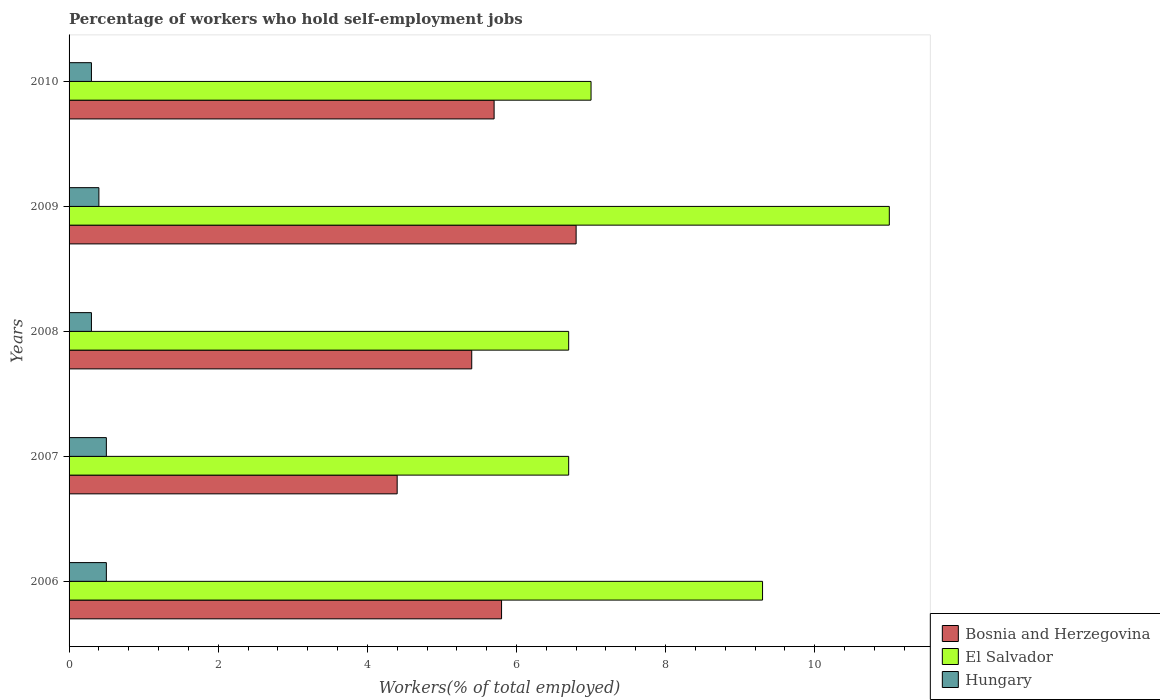How many different coloured bars are there?
Make the answer very short. 3. How many groups of bars are there?
Give a very brief answer. 5. Are the number of bars per tick equal to the number of legend labels?
Offer a very short reply. Yes. How many bars are there on the 3rd tick from the top?
Ensure brevity in your answer.  3. How many bars are there on the 4th tick from the bottom?
Your response must be concise. 3. What is the label of the 2nd group of bars from the top?
Ensure brevity in your answer.  2009. In how many cases, is the number of bars for a given year not equal to the number of legend labels?
Make the answer very short. 0. What is the percentage of self-employed workers in El Salvador in 2007?
Offer a very short reply. 6.7. Across all years, what is the maximum percentage of self-employed workers in Bosnia and Herzegovina?
Your answer should be compact. 6.8. Across all years, what is the minimum percentage of self-employed workers in Hungary?
Your response must be concise. 0.3. In which year was the percentage of self-employed workers in Bosnia and Herzegovina minimum?
Offer a very short reply. 2007. What is the total percentage of self-employed workers in El Salvador in the graph?
Provide a succinct answer. 40.7. What is the difference between the percentage of self-employed workers in Hungary in 2006 and that in 2007?
Your answer should be compact. 0. What is the difference between the percentage of self-employed workers in Bosnia and Herzegovina in 2010 and the percentage of self-employed workers in Hungary in 2006?
Your answer should be compact. 5.2. What is the average percentage of self-employed workers in El Salvador per year?
Give a very brief answer. 8.14. In the year 2006, what is the difference between the percentage of self-employed workers in Hungary and percentage of self-employed workers in Bosnia and Herzegovina?
Keep it short and to the point. -5.3. What is the ratio of the percentage of self-employed workers in El Salvador in 2008 to that in 2009?
Your answer should be compact. 0.61. Is the percentage of self-employed workers in El Salvador in 2009 less than that in 2010?
Give a very brief answer. No. Is the difference between the percentage of self-employed workers in Hungary in 2007 and 2008 greater than the difference between the percentage of self-employed workers in Bosnia and Herzegovina in 2007 and 2008?
Offer a terse response. Yes. What is the difference between the highest and the lowest percentage of self-employed workers in Hungary?
Give a very brief answer. 0.2. In how many years, is the percentage of self-employed workers in Hungary greater than the average percentage of self-employed workers in Hungary taken over all years?
Keep it short and to the point. 2. Is the sum of the percentage of self-employed workers in Bosnia and Herzegovina in 2007 and 2009 greater than the maximum percentage of self-employed workers in El Salvador across all years?
Give a very brief answer. Yes. What does the 1st bar from the top in 2006 represents?
Provide a short and direct response. Hungary. What does the 1st bar from the bottom in 2008 represents?
Your answer should be compact. Bosnia and Herzegovina. How many bars are there?
Give a very brief answer. 15. Are all the bars in the graph horizontal?
Provide a succinct answer. Yes. What is the difference between two consecutive major ticks on the X-axis?
Offer a terse response. 2. Are the values on the major ticks of X-axis written in scientific E-notation?
Make the answer very short. No. Does the graph contain any zero values?
Provide a short and direct response. No. What is the title of the graph?
Offer a very short reply. Percentage of workers who hold self-employment jobs. What is the label or title of the X-axis?
Provide a succinct answer. Workers(% of total employed). What is the Workers(% of total employed) of Bosnia and Herzegovina in 2006?
Give a very brief answer. 5.8. What is the Workers(% of total employed) of El Salvador in 2006?
Your answer should be very brief. 9.3. What is the Workers(% of total employed) in Hungary in 2006?
Your response must be concise. 0.5. What is the Workers(% of total employed) in Bosnia and Herzegovina in 2007?
Provide a short and direct response. 4.4. What is the Workers(% of total employed) of El Salvador in 2007?
Give a very brief answer. 6.7. What is the Workers(% of total employed) of Hungary in 2007?
Give a very brief answer. 0.5. What is the Workers(% of total employed) in Bosnia and Herzegovina in 2008?
Your answer should be compact. 5.4. What is the Workers(% of total employed) in El Salvador in 2008?
Give a very brief answer. 6.7. What is the Workers(% of total employed) in Hungary in 2008?
Give a very brief answer. 0.3. What is the Workers(% of total employed) of Bosnia and Herzegovina in 2009?
Your response must be concise. 6.8. What is the Workers(% of total employed) of Hungary in 2009?
Make the answer very short. 0.4. What is the Workers(% of total employed) of Bosnia and Herzegovina in 2010?
Offer a very short reply. 5.7. What is the Workers(% of total employed) in Hungary in 2010?
Give a very brief answer. 0.3. Across all years, what is the maximum Workers(% of total employed) in Bosnia and Herzegovina?
Offer a terse response. 6.8. Across all years, what is the minimum Workers(% of total employed) in Bosnia and Herzegovina?
Your answer should be very brief. 4.4. Across all years, what is the minimum Workers(% of total employed) of El Salvador?
Offer a terse response. 6.7. Across all years, what is the minimum Workers(% of total employed) in Hungary?
Keep it short and to the point. 0.3. What is the total Workers(% of total employed) of Bosnia and Herzegovina in the graph?
Offer a terse response. 28.1. What is the total Workers(% of total employed) of El Salvador in the graph?
Keep it short and to the point. 40.7. What is the difference between the Workers(% of total employed) in Bosnia and Herzegovina in 2006 and that in 2007?
Your response must be concise. 1.4. What is the difference between the Workers(% of total employed) in Hungary in 2006 and that in 2008?
Provide a succinct answer. 0.2. What is the difference between the Workers(% of total employed) of Bosnia and Herzegovina in 2006 and that in 2010?
Your response must be concise. 0.1. What is the difference between the Workers(% of total employed) of El Salvador in 2006 and that in 2010?
Your answer should be very brief. 2.3. What is the difference between the Workers(% of total employed) of Hungary in 2007 and that in 2008?
Offer a very short reply. 0.2. What is the difference between the Workers(% of total employed) of El Salvador in 2007 and that in 2009?
Keep it short and to the point. -4.3. What is the difference between the Workers(% of total employed) in El Salvador in 2007 and that in 2010?
Offer a very short reply. -0.3. What is the difference between the Workers(% of total employed) of El Salvador in 2008 and that in 2009?
Your answer should be compact. -4.3. What is the difference between the Workers(% of total employed) in Hungary in 2008 and that in 2010?
Provide a succinct answer. 0. What is the difference between the Workers(% of total employed) in Bosnia and Herzegovina in 2006 and the Workers(% of total employed) in El Salvador in 2007?
Your answer should be very brief. -0.9. What is the difference between the Workers(% of total employed) in Bosnia and Herzegovina in 2006 and the Workers(% of total employed) in Hungary in 2007?
Offer a terse response. 5.3. What is the difference between the Workers(% of total employed) of Bosnia and Herzegovina in 2006 and the Workers(% of total employed) of El Salvador in 2008?
Your answer should be very brief. -0.9. What is the difference between the Workers(% of total employed) in Bosnia and Herzegovina in 2006 and the Workers(% of total employed) in El Salvador in 2009?
Keep it short and to the point. -5.2. What is the difference between the Workers(% of total employed) in Bosnia and Herzegovina in 2006 and the Workers(% of total employed) in Hungary in 2009?
Your answer should be compact. 5.4. What is the difference between the Workers(% of total employed) of El Salvador in 2006 and the Workers(% of total employed) of Hungary in 2009?
Your response must be concise. 8.9. What is the difference between the Workers(% of total employed) of Bosnia and Herzegovina in 2006 and the Workers(% of total employed) of El Salvador in 2010?
Ensure brevity in your answer.  -1.2. What is the difference between the Workers(% of total employed) in Bosnia and Herzegovina in 2006 and the Workers(% of total employed) in Hungary in 2010?
Keep it short and to the point. 5.5. What is the difference between the Workers(% of total employed) of Bosnia and Herzegovina in 2007 and the Workers(% of total employed) of El Salvador in 2008?
Offer a terse response. -2.3. What is the difference between the Workers(% of total employed) of El Salvador in 2007 and the Workers(% of total employed) of Hungary in 2008?
Offer a terse response. 6.4. What is the difference between the Workers(% of total employed) of Bosnia and Herzegovina in 2007 and the Workers(% of total employed) of Hungary in 2009?
Keep it short and to the point. 4. What is the difference between the Workers(% of total employed) in El Salvador in 2007 and the Workers(% of total employed) in Hungary in 2009?
Keep it short and to the point. 6.3. What is the difference between the Workers(% of total employed) of Bosnia and Herzegovina in 2007 and the Workers(% of total employed) of El Salvador in 2010?
Your response must be concise. -2.6. What is the difference between the Workers(% of total employed) in El Salvador in 2007 and the Workers(% of total employed) in Hungary in 2010?
Your answer should be very brief. 6.4. What is the difference between the Workers(% of total employed) of Bosnia and Herzegovina in 2008 and the Workers(% of total employed) of El Salvador in 2009?
Provide a succinct answer. -5.6. What is the difference between the Workers(% of total employed) in El Salvador in 2008 and the Workers(% of total employed) in Hungary in 2010?
Your answer should be compact. 6.4. What is the difference between the Workers(% of total employed) of Bosnia and Herzegovina in 2009 and the Workers(% of total employed) of El Salvador in 2010?
Make the answer very short. -0.2. What is the difference between the Workers(% of total employed) of Bosnia and Herzegovina in 2009 and the Workers(% of total employed) of Hungary in 2010?
Ensure brevity in your answer.  6.5. What is the difference between the Workers(% of total employed) in El Salvador in 2009 and the Workers(% of total employed) in Hungary in 2010?
Make the answer very short. 10.7. What is the average Workers(% of total employed) in Bosnia and Herzegovina per year?
Keep it short and to the point. 5.62. What is the average Workers(% of total employed) in El Salvador per year?
Give a very brief answer. 8.14. In the year 2006, what is the difference between the Workers(% of total employed) of Bosnia and Herzegovina and Workers(% of total employed) of El Salvador?
Offer a very short reply. -3.5. In the year 2006, what is the difference between the Workers(% of total employed) in Bosnia and Herzegovina and Workers(% of total employed) in Hungary?
Offer a terse response. 5.3. In the year 2007, what is the difference between the Workers(% of total employed) of Bosnia and Herzegovina and Workers(% of total employed) of El Salvador?
Provide a short and direct response. -2.3. In the year 2007, what is the difference between the Workers(% of total employed) in Bosnia and Herzegovina and Workers(% of total employed) in Hungary?
Your answer should be compact. 3.9. In the year 2008, what is the difference between the Workers(% of total employed) of Bosnia and Herzegovina and Workers(% of total employed) of El Salvador?
Ensure brevity in your answer.  -1.3. In the year 2008, what is the difference between the Workers(% of total employed) of El Salvador and Workers(% of total employed) of Hungary?
Your answer should be very brief. 6.4. In the year 2009, what is the difference between the Workers(% of total employed) in Bosnia and Herzegovina and Workers(% of total employed) in El Salvador?
Offer a very short reply. -4.2. In the year 2009, what is the difference between the Workers(% of total employed) of Bosnia and Herzegovina and Workers(% of total employed) of Hungary?
Your answer should be compact. 6.4. In the year 2009, what is the difference between the Workers(% of total employed) of El Salvador and Workers(% of total employed) of Hungary?
Offer a terse response. 10.6. In the year 2010, what is the difference between the Workers(% of total employed) in Bosnia and Herzegovina and Workers(% of total employed) in El Salvador?
Ensure brevity in your answer.  -1.3. In the year 2010, what is the difference between the Workers(% of total employed) in El Salvador and Workers(% of total employed) in Hungary?
Ensure brevity in your answer.  6.7. What is the ratio of the Workers(% of total employed) in Bosnia and Herzegovina in 2006 to that in 2007?
Ensure brevity in your answer.  1.32. What is the ratio of the Workers(% of total employed) of El Salvador in 2006 to that in 2007?
Your answer should be very brief. 1.39. What is the ratio of the Workers(% of total employed) of Hungary in 2006 to that in 2007?
Your response must be concise. 1. What is the ratio of the Workers(% of total employed) of Bosnia and Herzegovina in 2006 to that in 2008?
Offer a terse response. 1.07. What is the ratio of the Workers(% of total employed) of El Salvador in 2006 to that in 2008?
Your response must be concise. 1.39. What is the ratio of the Workers(% of total employed) of Bosnia and Herzegovina in 2006 to that in 2009?
Offer a very short reply. 0.85. What is the ratio of the Workers(% of total employed) of El Salvador in 2006 to that in 2009?
Make the answer very short. 0.85. What is the ratio of the Workers(% of total employed) in Bosnia and Herzegovina in 2006 to that in 2010?
Your answer should be compact. 1.02. What is the ratio of the Workers(% of total employed) of El Salvador in 2006 to that in 2010?
Offer a terse response. 1.33. What is the ratio of the Workers(% of total employed) of Hungary in 2006 to that in 2010?
Provide a succinct answer. 1.67. What is the ratio of the Workers(% of total employed) in Bosnia and Herzegovina in 2007 to that in 2008?
Your answer should be compact. 0.81. What is the ratio of the Workers(% of total employed) in Hungary in 2007 to that in 2008?
Your response must be concise. 1.67. What is the ratio of the Workers(% of total employed) of Bosnia and Herzegovina in 2007 to that in 2009?
Your answer should be very brief. 0.65. What is the ratio of the Workers(% of total employed) in El Salvador in 2007 to that in 2009?
Ensure brevity in your answer.  0.61. What is the ratio of the Workers(% of total employed) in Bosnia and Herzegovina in 2007 to that in 2010?
Provide a short and direct response. 0.77. What is the ratio of the Workers(% of total employed) of El Salvador in 2007 to that in 2010?
Give a very brief answer. 0.96. What is the ratio of the Workers(% of total employed) in Hungary in 2007 to that in 2010?
Your response must be concise. 1.67. What is the ratio of the Workers(% of total employed) of Bosnia and Herzegovina in 2008 to that in 2009?
Offer a terse response. 0.79. What is the ratio of the Workers(% of total employed) of El Salvador in 2008 to that in 2009?
Make the answer very short. 0.61. What is the ratio of the Workers(% of total employed) in Hungary in 2008 to that in 2009?
Offer a very short reply. 0.75. What is the ratio of the Workers(% of total employed) in Bosnia and Herzegovina in 2008 to that in 2010?
Provide a succinct answer. 0.95. What is the ratio of the Workers(% of total employed) of El Salvador in 2008 to that in 2010?
Your response must be concise. 0.96. What is the ratio of the Workers(% of total employed) in Bosnia and Herzegovina in 2009 to that in 2010?
Your answer should be compact. 1.19. What is the ratio of the Workers(% of total employed) of El Salvador in 2009 to that in 2010?
Provide a succinct answer. 1.57. What is the ratio of the Workers(% of total employed) in Hungary in 2009 to that in 2010?
Provide a succinct answer. 1.33. What is the difference between the highest and the second highest Workers(% of total employed) of El Salvador?
Ensure brevity in your answer.  1.7. What is the difference between the highest and the second highest Workers(% of total employed) in Hungary?
Keep it short and to the point. 0. What is the difference between the highest and the lowest Workers(% of total employed) of Bosnia and Herzegovina?
Provide a succinct answer. 2.4. What is the difference between the highest and the lowest Workers(% of total employed) in El Salvador?
Ensure brevity in your answer.  4.3. 